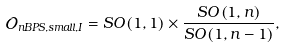Convert formula to latex. <formula><loc_0><loc_0><loc_500><loc_500>\mathcal { O } _ { n B P S , s m a l l , I } = S O \left ( 1 , 1 \right ) \times \frac { S O \left ( 1 , n \right ) } { S O \left ( 1 , n - 1 \right ) } ,</formula> 